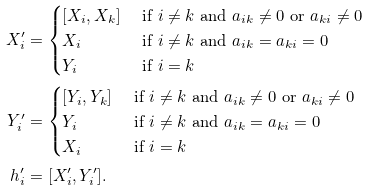<formula> <loc_0><loc_0><loc_500><loc_500>X _ { i } ^ { \prime } & = \begin{cases} [ X _ { i } , X _ { k } ] & \text { if } i \neq k \text { and } a _ { i k } \neq 0 \text { or } a _ { k i } \neq 0 \\ X _ { i } & \text { if } i \neq k \text { and } a _ { i k } = a _ { k i } = 0 \\ Y _ { i } & \text { if } i = k \end{cases} \\ Y _ { i } ^ { \prime } & = \begin{cases} [ Y _ { i } , Y _ { k } ] & \text { if } i \neq k \text { and } a _ { i k } \neq 0 \text { or } a _ { k i } \neq 0 \\ Y _ { i } & \text { if } i \neq k \text { and } a _ { i k } = a _ { k i } = 0 \\ X _ { i } & \text { if } i = k \end{cases} \\ h _ { i } ^ { \prime } & = [ X _ { i } ^ { \prime } , Y _ { i } ^ { \prime } ] .</formula> 